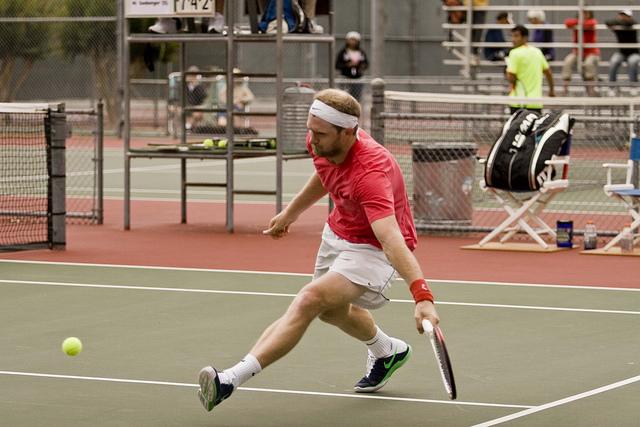What game is he playing?
Answer briefly. Tennis. What brand shoes is he wearing?
Give a very brief answer. Nike. Which leg is extended forward?
Give a very brief answer. Left. 